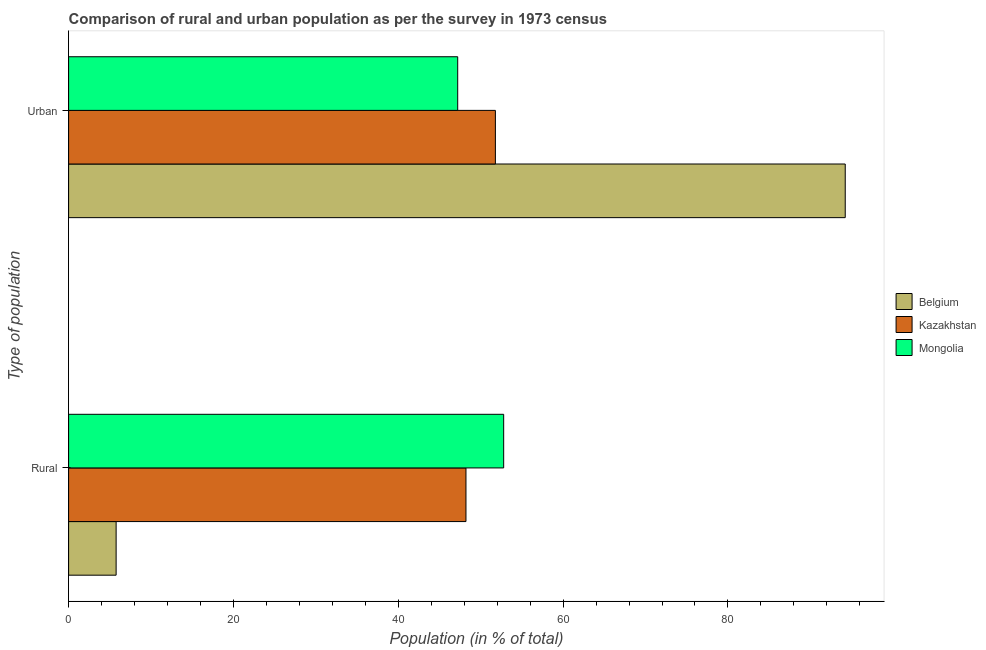How many different coloured bars are there?
Make the answer very short. 3. Are the number of bars on each tick of the Y-axis equal?
Your answer should be very brief. Yes. How many bars are there on the 2nd tick from the bottom?
Offer a very short reply. 3. What is the label of the 1st group of bars from the top?
Ensure brevity in your answer.  Urban. What is the rural population in Belgium?
Keep it short and to the point. 5.77. Across all countries, what is the maximum rural population?
Provide a succinct answer. 52.79. Across all countries, what is the minimum rural population?
Your answer should be compact. 5.77. In which country was the urban population maximum?
Make the answer very short. Belgium. What is the total urban population in the graph?
Keep it short and to the point. 193.23. What is the difference between the rural population in Mongolia and that in Kazakhstan?
Your answer should be compact. 4.57. What is the difference between the urban population in Belgium and the rural population in Mongolia?
Offer a very short reply. 41.44. What is the average rural population per country?
Offer a terse response. 35.59. What is the difference between the rural population and urban population in Belgium?
Keep it short and to the point. -88.47. In how many countries, is the rural population greater than 76 %?
Keep it short and to the point. 0. What is the ratio of the urban population in Mongolia to that in Belgium?
Give a very brief answer. 0.5. Is the rural population in Belgium less than that in Kazakhstan?
Your response must be concise. Yes. In how many countries, is the urban population greater than the average urban population taken over all countries?
Your response must be concise. 1. What does the 2nd bar from the bottom in Urban represents?
Offer a terse response. Kazakhstan. How many bars are there?
Your answer should be compact. 6. How many countries are there in the graph?
Make the answer very short. 3. Are the values on the major ticks of X-axis written in scientific E-notation?
Offer a terse response. No. Does the graph contain any zero values?
Provide a short and direct response. No. Does the graph contain grids?
Keep it short and to the point. No. Where does the legend appear in the graph?
Your response must be concise. Center right. How many legend labels are there?
Your answer should be very brief. 3. How are the legend labels stacked?
Offer a terse response. Vertical. What is the title of the graph?
Provide a short and direct response. Comparison of rural and urban population as per the survey in 1973 census. Does "Australia" appear as one of the legend labels in the graph?
Your answer should be very brief. No. What is the label or title of the X-axis?
Make the answer very short. Population (in % of total). What is the label or title of the Y-axis?
Keep it short and to the point. Type of population. What is the Population (in % of total) of Belgium in Rural?
Offer a very short reply. 5.77. What is the Population (in % of total) in Kazakhstan in Rural?
Make the answer very short. 48.22. What is the Population (in % of total) of Mongolia in Rural?
Offer a terse response. 52.79. What is the Population (in % of total) of Belgium in Urban?
Make the answer very short. 94.23. What is the Population (in % of total) of Kazakhstan in Urban?
Make the answer very short. 51.78. What is the Population (in % of total) in Mongolia in Urban?
Your answer should be compact. 47.21. Across all Type of population, what is the maximum Population (in % of total) of Belgium?
Provide a short and direct response. 94.23. Across all Type of population, what is the maximum Population (in % of total) in Kazakhstan?
Provide a short and direct response. 51.78. Across all Type of population, what is the maximum Population (in % of total) of Mongolia?
Your answer should be very brief. 52.79. Across all Type of population, what is the minimum Population (in % of total) in Belgium?
Provide a short and direct response. 5.77. Across all Type of population, what is the minimum Population (in % of total) in Kazakhstan?
Your response must be concise. 48.22. Across all Type of population, what is the minimum Population (in % of total) in Mongolia?
Provide a short and direct response. 47.21. What is the total Population (in % of total) of Belgium in the graph?
Give a very brief answer. 100. What is the total Population (in % of total) of Kazakhstan in the graph?
Keep it short and to the point. 100. What is the difference between the Population (in % of total) in Belgium in Rural and that in Urban?
Your answer should be compact. -88.47. What is the difference between the Population (in % of total) of Kazakhstan in Rural and that in Urban?
Keep it short and to the point. -3.57. What is the difference between the Population (in % of total) in Mongolia in Rural and that in Urban?
Offer a very short reply. 5.58. What is the difference between the Population (in % of total) in Belgium in Rural and the Population (in % of total) in Kazakhstan in Urban?
Offer a very short reply. -46.02. What is the difference between the Population (in % of total) in Belgium in Rural and the Population (in % of total) in Mongolia in Urban?
Your answer should be compact. -41.44. What is the difference between the Population (in % of total) in Kazakhstan in Rural and the Population (in % of total) in Mongolia in Urban?
Give a very brief answer. 1. What is the average Population (in % of total) in Belgium per Type of population?
Your answer should be very brief. 50. What is the average Population (in % of total) in Kazakhstan per Type of population?
Your response must be concise. 50. What is the average Population (in % of total) in Mongolia per Type of population?
Give a very brief answer. 50. What is the difference between the Population (in % of total) in Belgium and Population (in % of total) in Kazakhstan in Rural?
Give a very brief answer. -42.45. What is the difference between the Population (in % of total) of Belgium and Population (in % of total) of Mongolia in Rural?
Keep it short and to the point. -47.02. What is the difference between the Population (in % of total) in Kazakhstan and Population (in % of total) in Mongolia in Rural?
Your answer should be very brief. -4.57. What is the difference between the Population (in % of total) in Belgium and Population (in % of total) in Kazakhstan in Urban?
Offer a terse response. 42.45. What is the difference between the Population (in % of total) in Belgium and Population (in % of total) in Mongolia in Urban?
Your response must be concise. 47.02. What is the difference between the Population (in % of total) in Kazakhstan and Population (in % of total) in Mongolia in Urban?
Provide a short and direct response. 4.57. What is the ratio of the Population (in % of total) of Belgium in Rural to that in Urban?
Your answer should be very brief. 0.06. What is the ratio of the Population (in % of total) in Kazakhstan in Rural to that in Urban?
Offer a very short reply. 0.93. What is the ratio of the Population (in % of total) in Mongolia in Rural to that in Urban?
Ensure brevity in your answer.  1.12. What is the difference between the highest and the second highest Population (in % of total) of Belgium?
Your response must be concise. 88.47. What is the difference between the highest and the second highest Population (in % of total) in Kazakhstan?
Your response must be concise. 3.57. What is the difference between the highest and the second highest Population (in % of total) in Mongolia?
Ensure brevity in your answer.  5.58. What is the difference between the highest and the lowest Population (in % of total) in Belgium?
Make the answer very short. 88.47. What is the difference between the highest and the lowest Population (in % of total) of Kazakhstan?
Provide a succinct answer. 3.57. What is the difference between the highest and the lowest Population (in % of total) in Mongolia?
Offer a terse response. 5.58. 